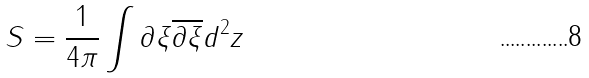<formula> <loc_0><loc_0><loc_500><loc_500>S = \frac { 1 } { 4 \pi } \int \partial \xi \overline { \partial } \overline { \xi } d ^ { 2 } z</formula> 